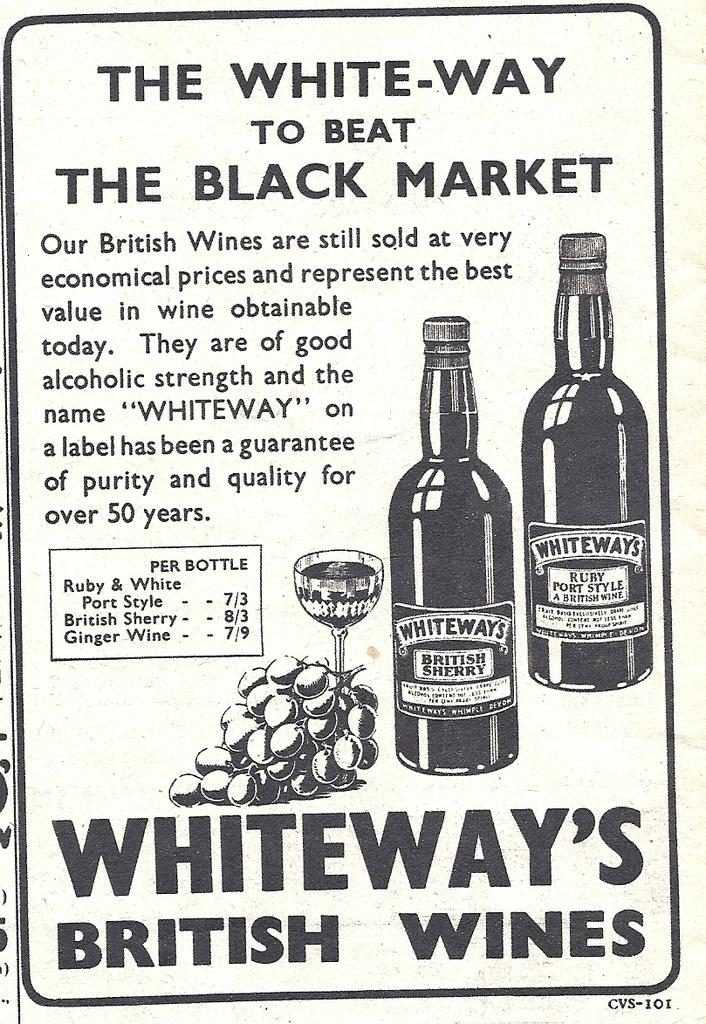<image>
Offer a succinct explanation of the picture presented. An advertisement in black and written by Whiteways British Wines. 